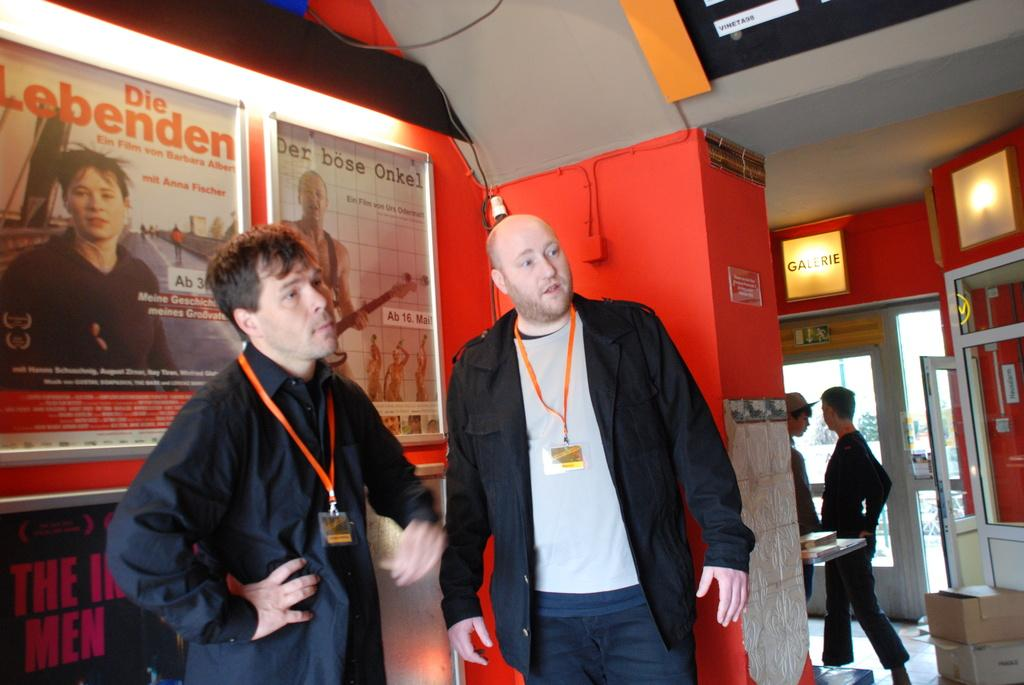How many people are in the image? There are two people in the image. What are the people wearing that can be seen in the image? The people are wearing identity cards. What are the people doing in the image? The people are standing. What can be seen on the walls in the image? There are posters in the image. What type of architectural features are present in the image? There is a glass door and a glass window in the image. What is located on the right side of the image? There are stock boxes on the right side of the image. Is there any blood visible on the people in the image? No, there is no blood visible on the people in the image. What type of property is being managed by the people in the image? The image does not provide any information about the people managing property. 